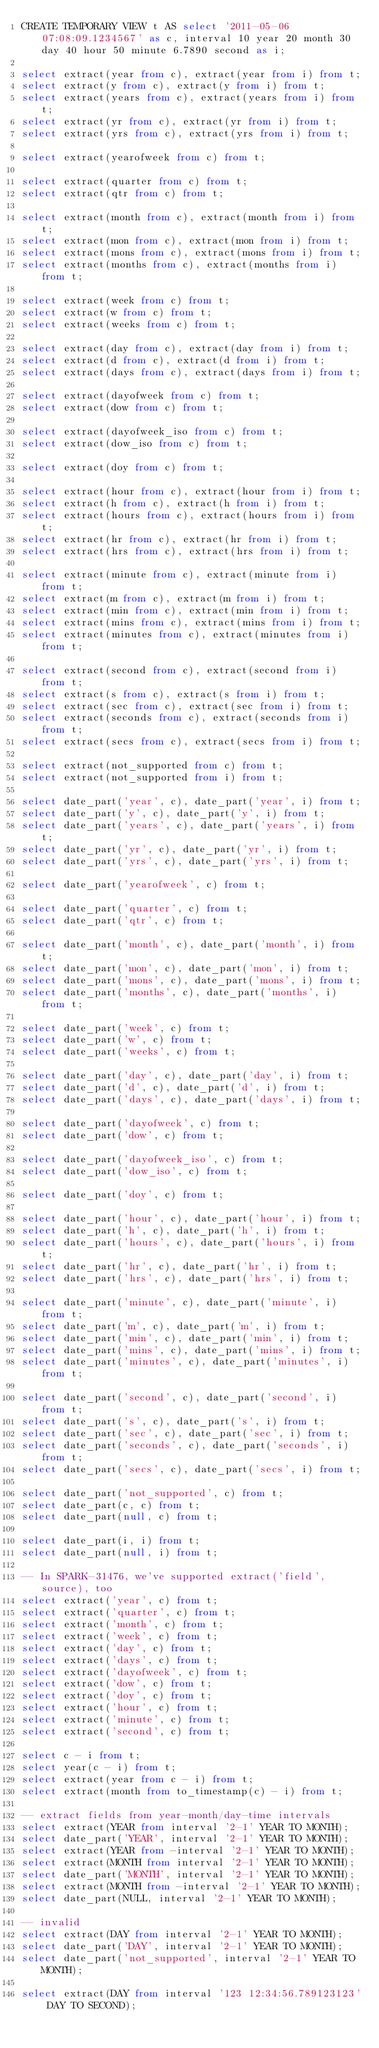<code> <loc_0><loc_0><loc_500><loc_500><_SQL_>CREATE TEMPORARY VIEW t AS select '2011-05-06 07:08:09.1234567' as c, interval 10 year 20 month 30 day 40 hour 50 minute 6.7890 second as i;

select extract(year from c), extract(year from i) from t;
select extract(y from c), extract(y from i) from t;
select extract(years from c), extract(years from i) from t;
select extract(yr from c), extract(yr from i) from t;
select extract(yrs from c), extract(yrs from i) from t;

select extract(yearofweek from c) from t;

select extract(quarter from c) from t;
select extract(qtr from c) from t;

select extract(month from c), extract(month from i) from t;
select extract(mon from c), extract(mon from i) from t;
select extract(mons from c), extract(mons from i) from t;
select extract(months from c), extract(months from i) from t;

select extract(week from c) from t;
select extract(w from c) from t;
select extract(weeks from c) from t;

select extract(day from c), extract(day from i) from t;
select extract(d from c), extract(d from i) from t;
select extract(days from c), extract(days from i) from t;

select extract(dayofweek from c) from t;
select extract(dow from c) from t;

select extract(dayofweek_iso from c) from t;
select extract(dow_iso from c) from t;

select extract(doy from c) from t;

select extract(hour from c), extract(hour from i) from t;
select extract(h from c), extract(h from i) from t;
select extract(hours from c), extract(hours from i) from t;
select extract(hr from c), extract(hr from i) from t;
select extract(hrs from c), extract(hrs from i) from t;

select extract(minute from c), extract(minute from i) from t;
select extract(m from c), extract(m from i) from t;
select extract(min from c), extract(min from i) from t;
select extract(mins from c), extract(mins from i) from t;
select extract(minutes from c), extract(minutes from i) from t;

select extract(second from c), extract(second from i) from t;
select extract(s from c), extract(s from i) from t;
select extract(sec from c), extract(sec from i) from t;
select extract(seconds from c), extract(seconds from i) from t;
select extract(secs from c), extract(secs from i) from t;

select extract(not_supported from c) from t;
select extract(not_supported from i) from t;

select date_part('year', c), date_part('year', i) from t;
select date_part('y', c), date_part('y', i) from t;
select date_part('years', c), date_part('years', i) from t;
select date_part('yr', c), date_part('yr', i) from t;
select date_part('yrs', c), date_part('yrs', i) from t;

select date_part('yearofweek', c) from t;

select date_part('quarter', c) from t;
select date_part('qtr', c) from t;

select date_part('month', c), date_part('month', i) from t;
select date_part('mon', c), date_part('mon', i) from t;
select date_part('mons', c), date_part('mons', i) from t;
select date_part('months', c), date_part('months', i) from t;

select date_part('week', c) from t;
select date_part('w', c) from t;
select date_part('weeks', c) from t;

select date_part('day', c), date_part('day', i) from t;
select date_part('d', c), date_part('d', i) from t;
select date_part('days', c), date_part('days', i) from t;

select date_part('dayofweek', c) from t;
select date_part('dow', c) from t;

select date_part('dayofweek_iso', c) from t;
select date_part('dow_iso', c) from t;

select date_part('doy', c) from t;

select date_part('hour', c), date_part('hour', i) from t;
select date_part('h', c), date_part('h', i) from t;
select date_part('hours', c), date_part('hours', i) from t;
select date_part('hr', c), date_part('hr', i) from t;
select date_part('hrs', c), date_part('hrs', i) from t;

select date_part('minute', c), date_part('minute', i) from t;
select date_part('m', c), date_part('m', i) from t;
select date_part('min', c), date_part('min', i) from t;
select date_part('mins', c), date_part('mins', i) from t;
select date_part('minutes', c), date_part('minutes', i) from t;

select date_part('second', c), date_part('second', i) from t;
select date_part('s', c), date_part('s', i) from t;
select date_part('sec', c), date_part('sec', i) from t;
select date_part('seconds', c), date_part('seconds', i) from t;
select date_part('secs', c), date_part('secs', i) from t;

select date_part('not_supported', c) from t;
select date_part(c, c) from t;
select date_part(null, c) from t;

select date_part(i, i) from t;
select date_part(null, i) from t;

-- In SPARK-31476, we've supported extract('field', source), too
select extract('year', c) from t;
select extract('quarter', c) from t;
select extract('month', c) from t;
select extract('week', c) from t;
select extract('day', c) from t;
select extract('days', c) from t;
select extract('dayofweek', c) from t;
select extract('dow', c) from t;
select extract('doy', c) from t;
select extract('hour', c) from t;
select extract('minute', c) from t;
select extract('second', c) from t;

select c - i from t;
select year(c - i) from t;
select extract(year from c - i) from t;
select extract(month from to_timestamp(c) - i) from t;

-- extract fields from year-month/day-time intervals
select extract(YEAR from interval '2-1' YEAR TO MONTH);
select date_part('YEAR', interval '2-1' YEAR TO MONTH);
select extract(YEAR from -interval '2-1' YEAR TO MONTH);
select extract(MONTH from interval '2-1' YEAR TO MONTH);
select date_part('MONTH', interval '2-1' YEAR TO MONTH);
select extract(MONTH from -interval '2-1' YEAR TO MONTH);
select date_part(NULL, interval '2-1' YEAR TO MONTH);

-- invalid
select extract(DAY from interval '2-1' YEAR TO MONTH);
select date_part('DAY', interval '2-1' YEAR TO MONTH);
select date_part('not_supported', interval '2-1' YEAR TO MONTH);

select extract(DAY from interval '123 12:34:56.789123123' DAY TO SECOND);</code> 